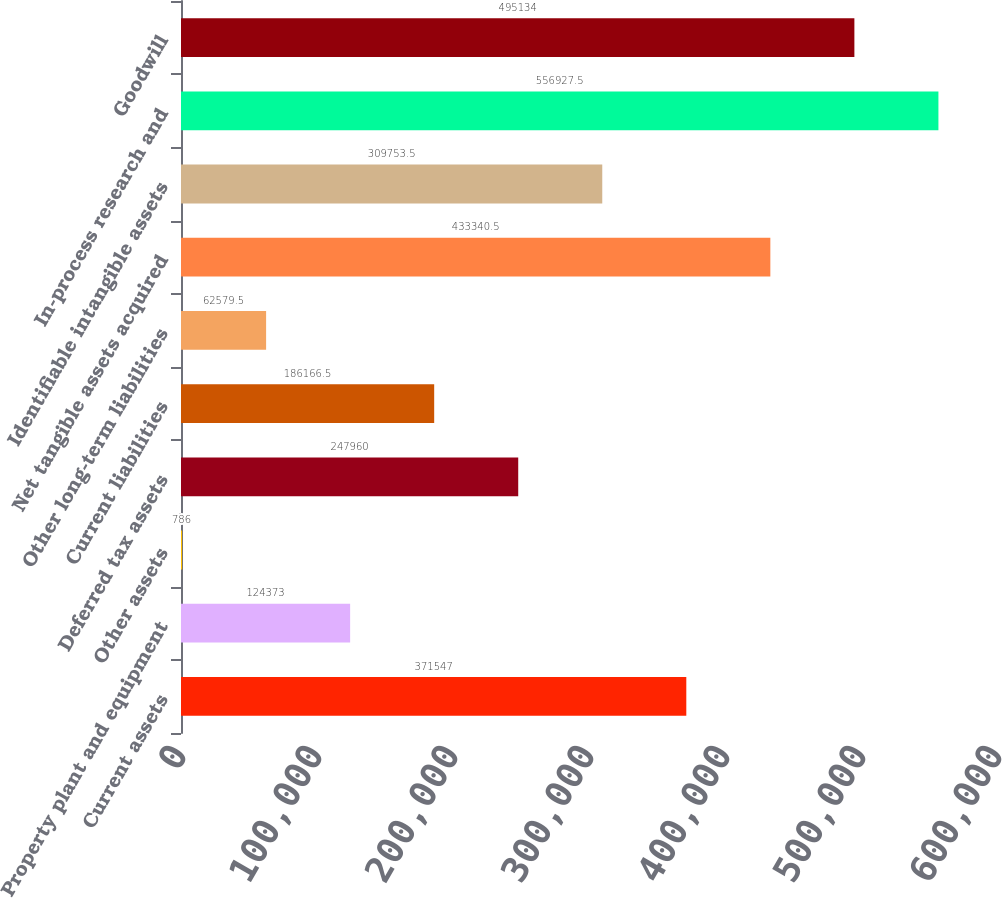<chart> <loc_0><loc_0><loc_500><loc_500><bar_chart><fcel>Current assets<fcel>Property plant and equipment<fcel>Other assets<fcel>Deferred tax assets<fcel>Current liabilities<fcel>Other long-term liabilities<fcel>Net tangible assets acquired<fcel>Identifiable intangible assets<fcel>In-process research and<fcel>Goodwill<nl><fcel>371547<fcel>124373<fcel>786<fcel>247960<fcel>186166<fcel>62579.5<fcel>433340<fcel>309754<fcel>556928<fcel>495134<nl></chart> 